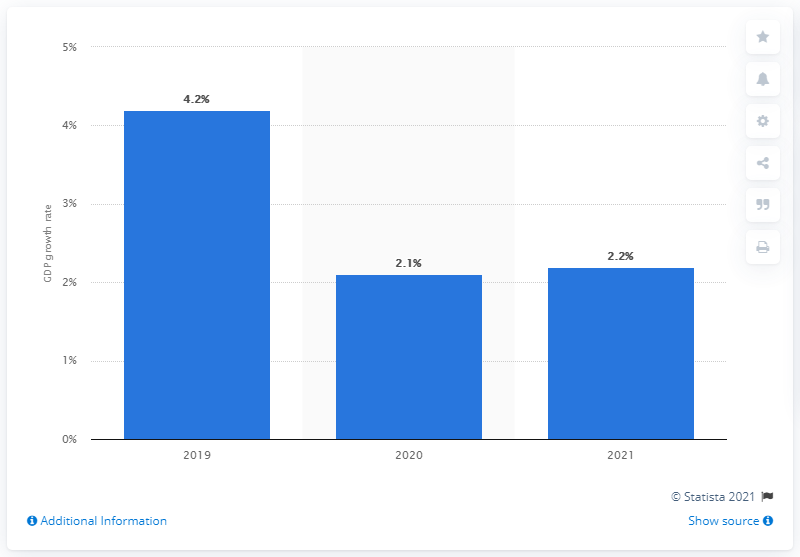Mention a couple of crucial points in this snapshot. The projected GDP growth in Romania is expected to slow down by the end of this year, to a rate of 2.1%. The GDP forecast for Romania is for the year 2021. 